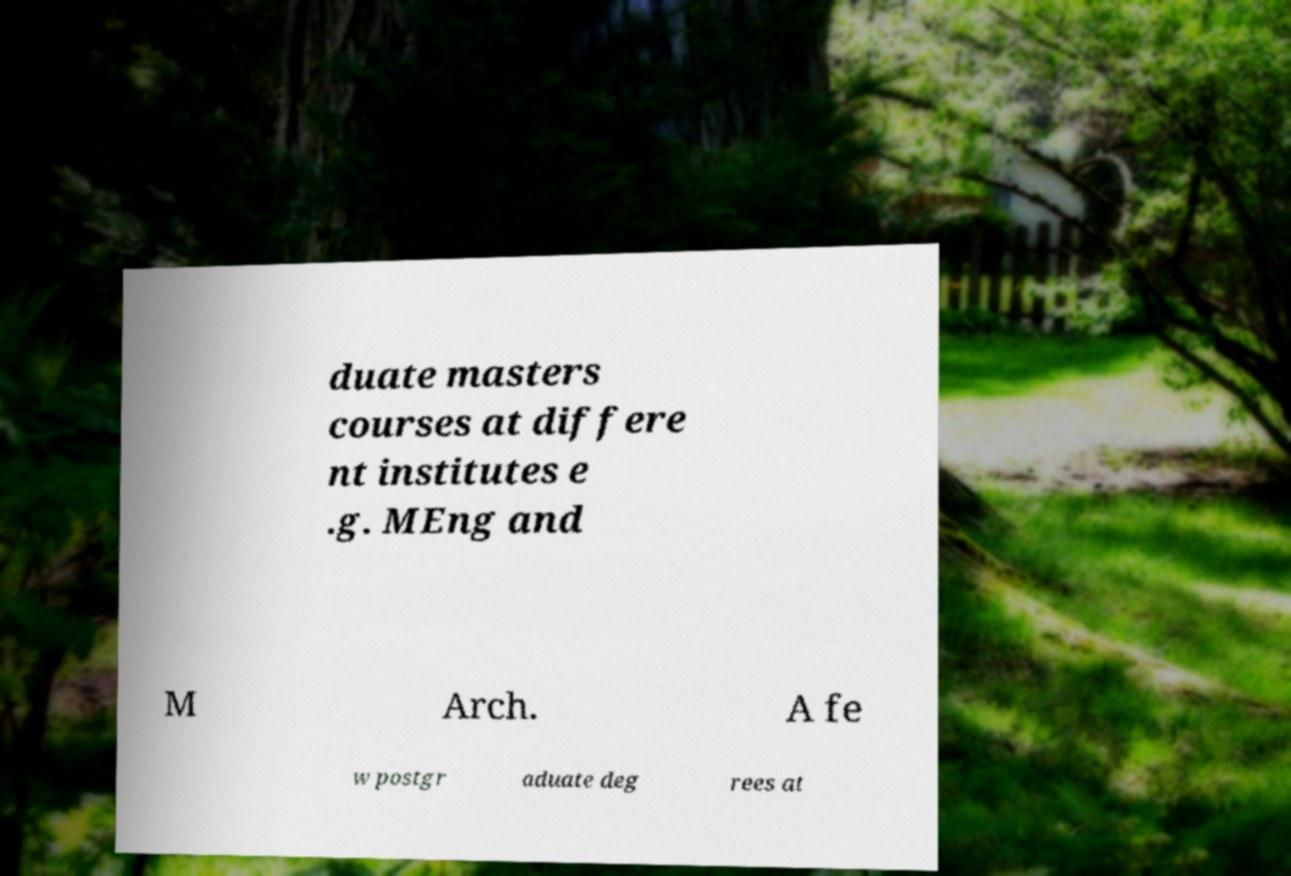There's text embedded in this image that I need extracted. Can you transcribe it verbatim? duate masters courses at differe nt institutes e .g. MEng and M Arch. A fe w postgr aduate deg rees at 